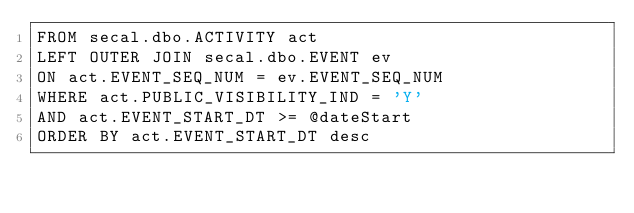<code> <loc_0><loc_0><loc_500><loc_500><_SQL_>FROM secal.dbo.ACTIVITY act
LEFT OUTER JOIN secal.dbo.EVENT ev
ON act.EVENT_SEQ_NUM = ev.EVENT_SEQ_NUM
WHERE act.PUBLIC_VISIBILITY_IND = 'Y'
AND act.EVENT_START_DT >= @dateStart
ORDER BY act.EVENT_START_DT desc
</code> 